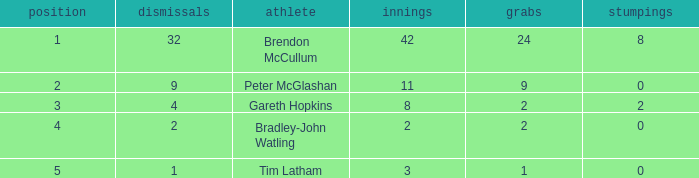List the ranks of all dismissals with a value of 4 3.0. Could you parse the entire table? {'header': ['position', 'dismissals', 'athlete', 'innings', 'grabs', 'stumpings'], 'rows': [['1', '32', 'Brendon McCullum', '42', '24', '8'], ['2', '9', 'Peter McGlashan', '11', '9', '0'], ['3', '4', 'Gareth Hopkins', '8', '2', '2'], ['4', '2', 'Bradley-John Watling', '2', '2', '0'], ['5', '1', 'Tim Latham', '3', '1', '0']]} 